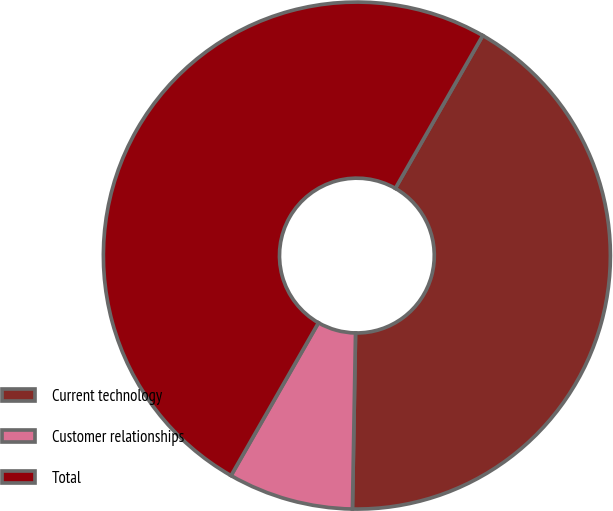Convert chart. <chart><loc_0><loc_0><loc_500><loc_500><pie_chart><fcel>Current technology<fcel>Customer relationships<fcel>Total<nl><fcel>42.01%<fcel>7.99%<fcel>50.0%<nl></chart> 